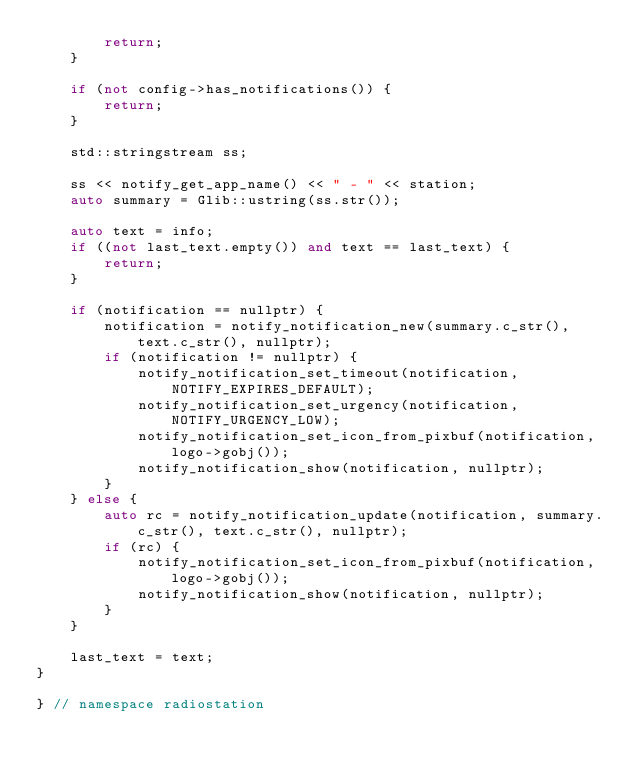<code> <loc_0><loc_0><loc_500><loc_500><_C++_>        return;
    }

    if (not config->has_notifications()) {
        return;
    }

    std::stringstream ss;

    ss << notify_get_app_name() << " - " << station;
    auto summary = Glib::ustring(ss.str());

    auto text = info;
    if ((not last_text.empty()) and text == last_text) {
        return;
    }

    if (notification == nullptr) {
        notification = notify_notification_new(summary.c_str(), text.c_str(), nullptr);
        if (notification != nullptr) {
            notify_notification_set_timeout(notification, NOTIFY_EXPIRES_DEFAULT);
            notify_notification_set_urgency(notification, NOTIFY_URGENCY_LOW);
            notify_notification_set_icon_from_pixbuf(notification, logo->gobj());
            notify_notification_show(notification, nullptr);
        }
    } else {
        auto rc = notify_notification_update(notification, summary.c_str(), text.c_str(), nullptr);
        if (rc) {
            notify_notification_set_icon_from_pixbuf(notification, logo->gobj());
            notify_notification_show(notification, nullptr);
        }
    }

    last_text = text;
}

} // namespace radiostation
</code> 